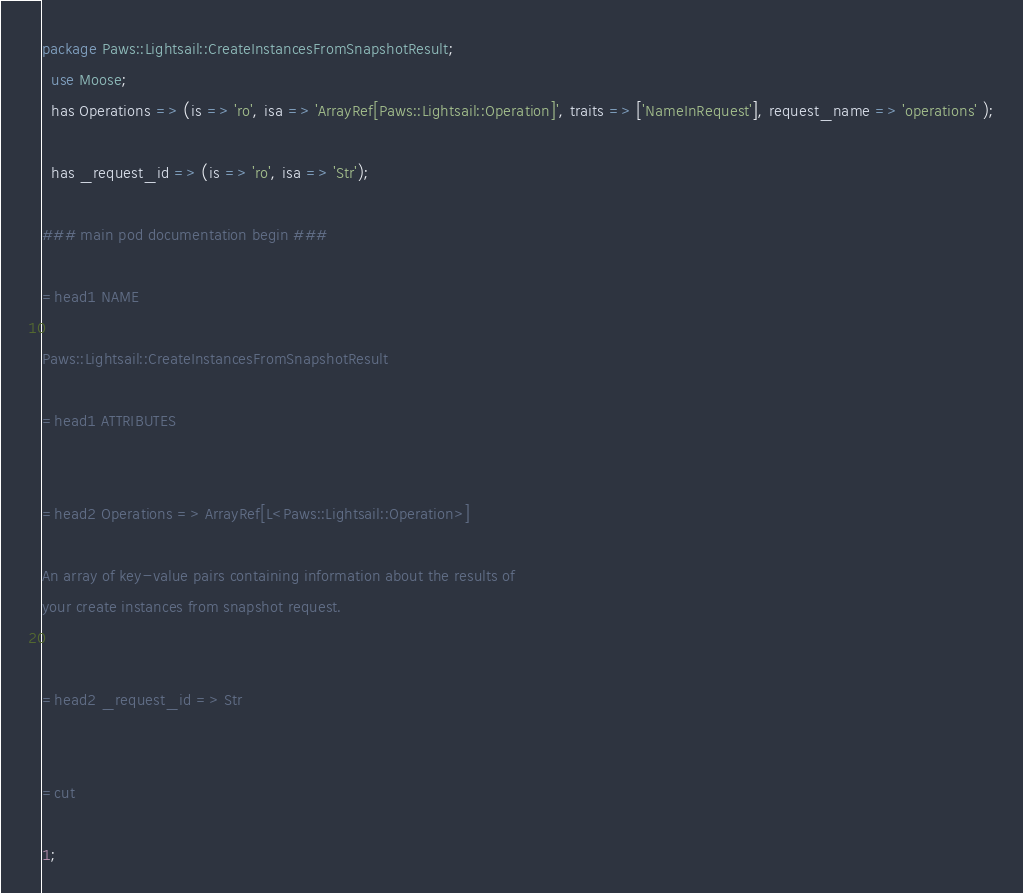<code> <loc_0><loc_0><loc_500><loc_500><_Perl_>
package Paws::Lightsail::CreateInstancesFromSnapshotResult;
  use Moose;
  has Operations => (is => 'ro', isa => 'ArrayRef[Paws::Lightsail::Operation]', traits => ['NameInRequest'], request_name => 'operations' );

  has _request_id => (is => 'ro', isa => 'Str');

### main pod documentation begin ###

=head1 NAME

Paws::Lightsail::CreateInstancesFromSnapshotResult

=head1 ATTRIBUTES


=head2 Operations => ArrayRef[L<Paws::Lightsail::Operation>]

An array of key-value pairs containing information about the results of
your create instances from snapshot request.


=head2 _request_id => Str


=cut

1;</code> 